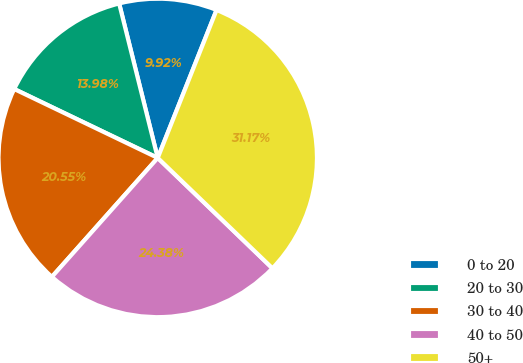<chart> <loc_0><loc_0><loc_500><loc_500><pie_chart><fcel>0 to 20<fcel>20 to 30<fcel>30 to 40<fcel>40 to 50<fcel>50+<nl><fcel>9.92%<fcel>13.98%<fcel>20.55%<fcel>24.38%<fcel>31.17%<nl></chart> 